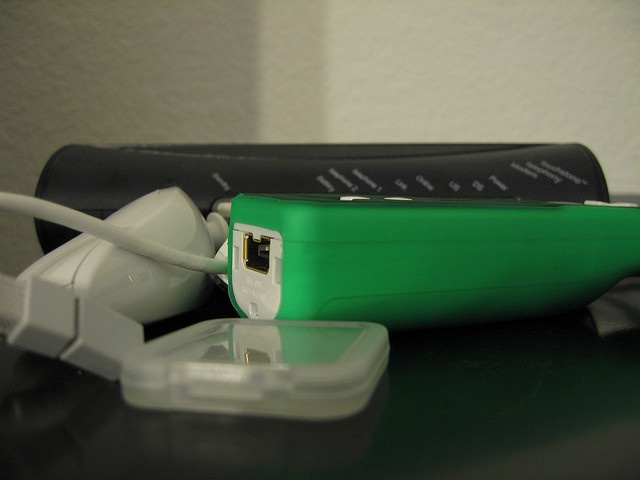Describe the objects in this image and their specific colors. I can see remote in gray, darkgreen, black, green, and darkgray tones, remote in gray, black, and darkgreen tones, cell phone in gray, green, and darkgray tones, and remote in gray, darkgray, and black tones in this image. 